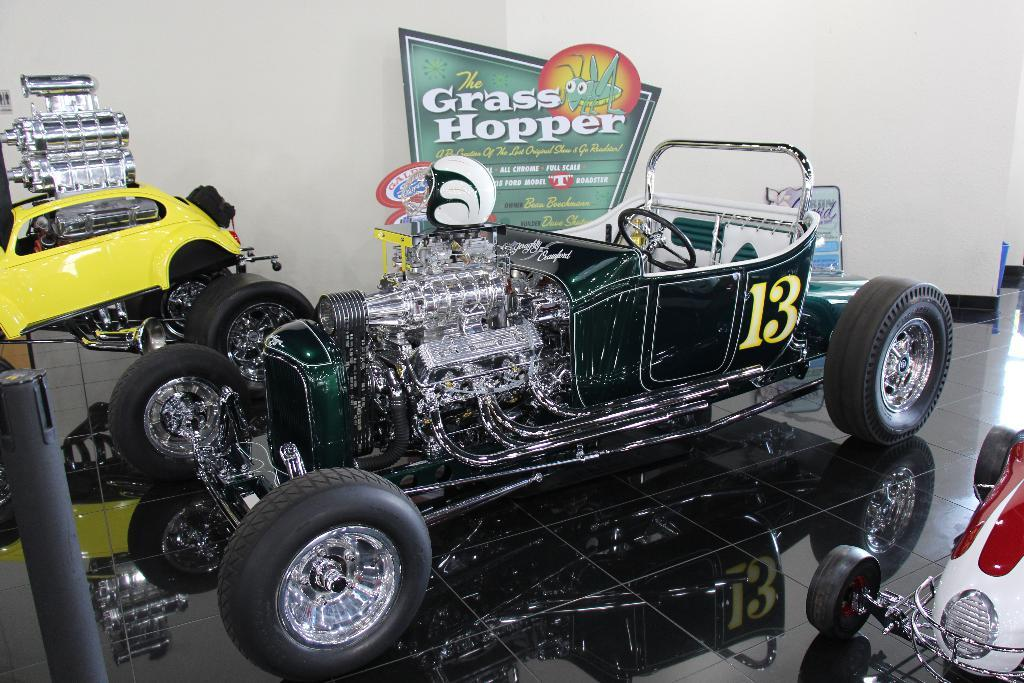What color is the car that is parked on the floor in the image? There is a green car in the image that is parked on the floor. What color is the other car in the image? The other car in the image is yellow. Where is the yellow car parked in relation to the wall? The yellow car is parked near a wall in the image. What additional feature can be seen in the image? There is a banner visible in the image. What degree does the grandfather have in the image? There is no mention of a grandfather or any degrees in the image. 